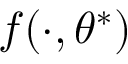Convert formula to latex. <formula><loc_0><loc_0><loc_500><loc_500>f ( \cdot , \theta ^ { * } )</formula> 